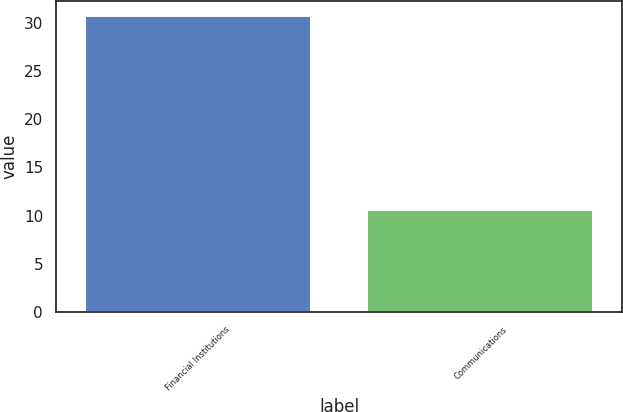<chart> <loc_0><loc_0><loc_500><loc_500><bar_chart><fcel>Financial Institutions<fcel>Communications<nl><fcel>30.7<fcel>10.6<nl></chart> 